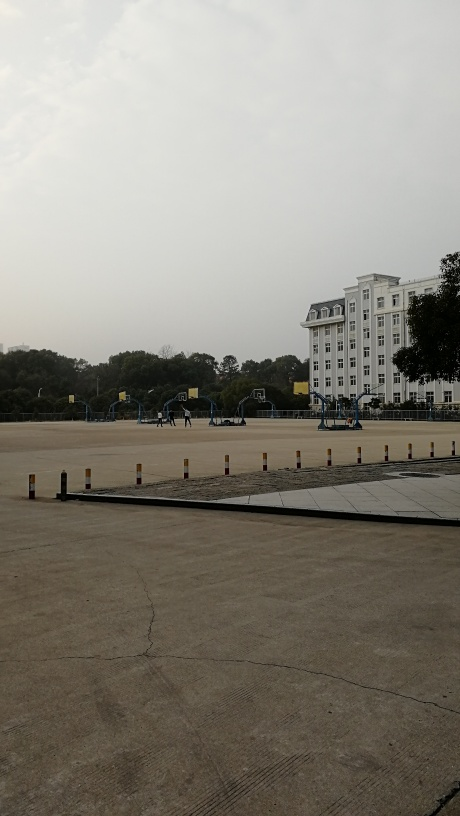What is the atmosphere of the location depicted in the image? The location in the image appears serene and quiet, with a spacious outdoor area and a formal-looking building that might suggest an institutional setting, such as an academic or government establishment. The lack of people and the stillness of the basketball courts give off an atmosphere of calm and order. Can you speculate which part of the day this photo was taken? The long shadows and soft lighting suggest that the photo was likely taken in the early morning or late afternoon. The absence of harsh sunlight and the fact that the sky isn't brightly lit point to times when the sun isn't at its zenith. 